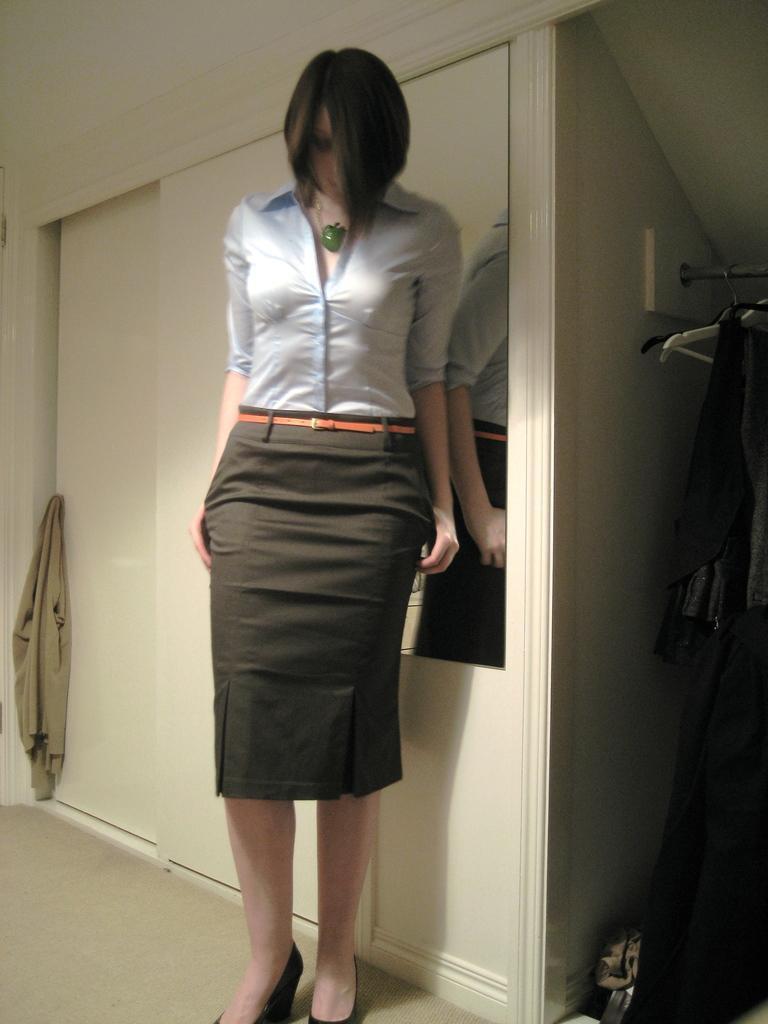Could you give a brief overview of what you see in this image? In this image we can see a woman standing on the floor, clothes hanged to the hangers and cupboard. 